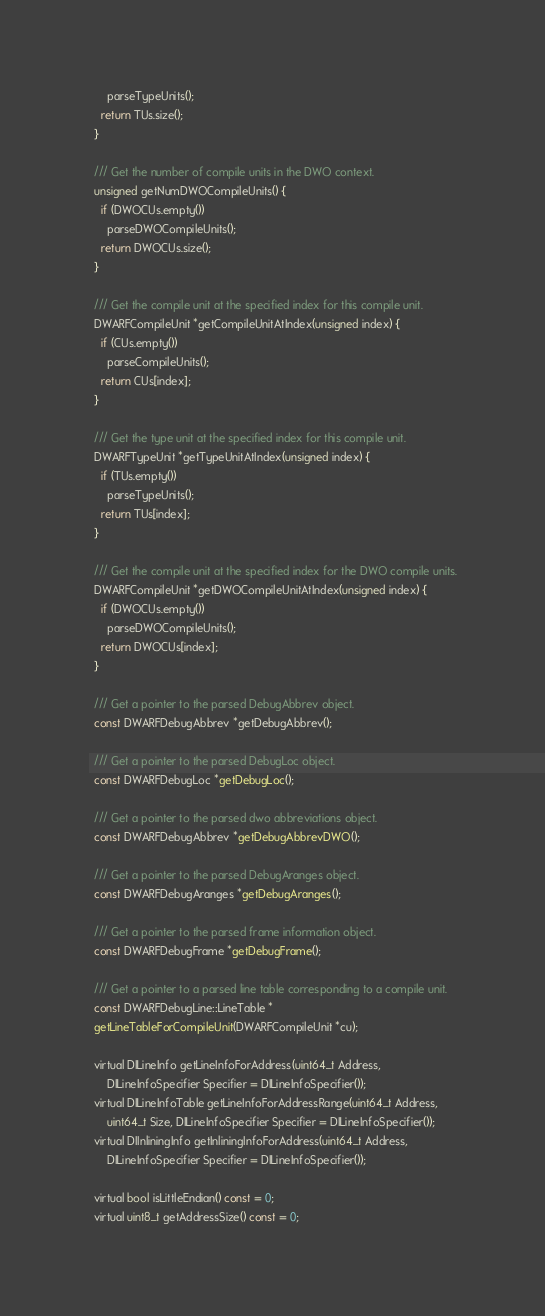Convert code to text. <code><loc_0><loc_0><loc_500><loc_500><_C_>      parseTypeUnits();
    return TUs.size();
  }

  /// Get the number of compile units in the DWO context.
  unsigned getNumDWOCompileUnits() {
    if (DWOCUs.empty())
      parseDWOCompileUnits();
    return DWOCUs.size();
  }

  /// Get the compile unit at the specified index for this compile unit.
  DWARFCompileUnit *getCompileUnitAtIndex(unsigned index) {
    if (CUs.empty())
      parseCompileUnits();
    return CUs[index];
  }

  /// Get the type unit at the specified index for this compile unit.
  DWARFTypeUnit *getTypeUnitAtIndex(unsigned index) {
    if (TUs.empty())
      parseTypeUnits();
    return TUs[index];
  }

  /// Get the compile unit at the specified index for the DWO compile units.
  DWARFCompileUnit *getDWOCompileUnitAtIndex(unsigned index) {
    if (DWOCUs.empty())
      parseDWOCompileUnits();
    return DWOCUs[index];
  }

  /// Get a pointer to the parsed DebugAbbrev object.
  const DWARFDebugAbbrev *getDebugAbbrev();

  /// Get a pointer to the parsed DebugLoc object.
  const DWARFDebugLoc *getDebugLoc();

  /// Get a pointer to the parsed dwo abbreviations object.
  const DWARFDebugAbbrev *getDebugAbbrevDWO();

  /// Get a pointer to the parsed DebugAranges object.
  const DWARFDebugAranges *getDebugAranges();

  /// Get a pointer to the parsed frame information object.
  const DWARFDebugFrame *getDebugFrame();

  /// Get a pointer to a parsed line table corresponding to a compile unit.
  const DWARFDebugLine::LineTable *
  getLineTableForCompileUnit(DWARFCompileUnit *cu);

  virtual DILineInfo getLineInfoForAddress(uint64_t Address,
      DILineInfoSpecifier Specifier = DILineInfoSpecifier());
  virtual DILineInfoTable getLineInfoForAddressRange(uint64_t Address,
      uint64_t Size, DILineInfoSpecifier Specifier = DILineInfoSpecifier());
  virtual DIInliningInfo getInliningInfoForAddress(uint64_t Address,
      DILineInfoSpecifier Specifier = DILineInfoSpecifier());

  virtual bool isLittleEndian() const = 0;
  virtual uint8_t getAddressSize() const = 0;</code> 